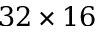<formula> <loc_0><loc_0><loc_500><loc_500>3 2 \times 1 6</formula> 